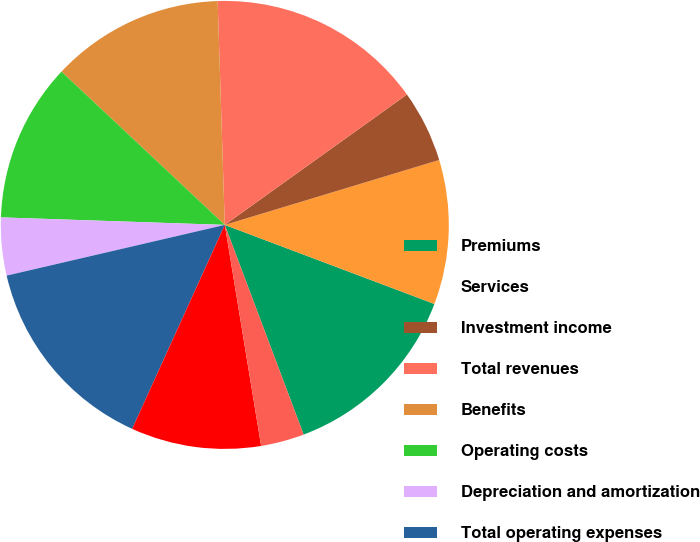<chart> <loc_0><loc_0><loc_500><loc_500><pie_chart><fcel>Premiums<fcel>Services<fcel>Investment income<fcel>Total revenues<fcel>Benefits<fcel>Operating costs<fcel>Depreciation and amortization<fcel>Total operating expenses<fcel>Income from operations<fcel>Interest expense<nl><fcel>13.54%<fcel>10.42%<fcel>5.21%<fcel>15.62%<fcel>12.5%<fcel>11.46%<fcel>4.17%<fcel>14.58%<fcel>9.38%<fcel>3.13%<nl></chart> 